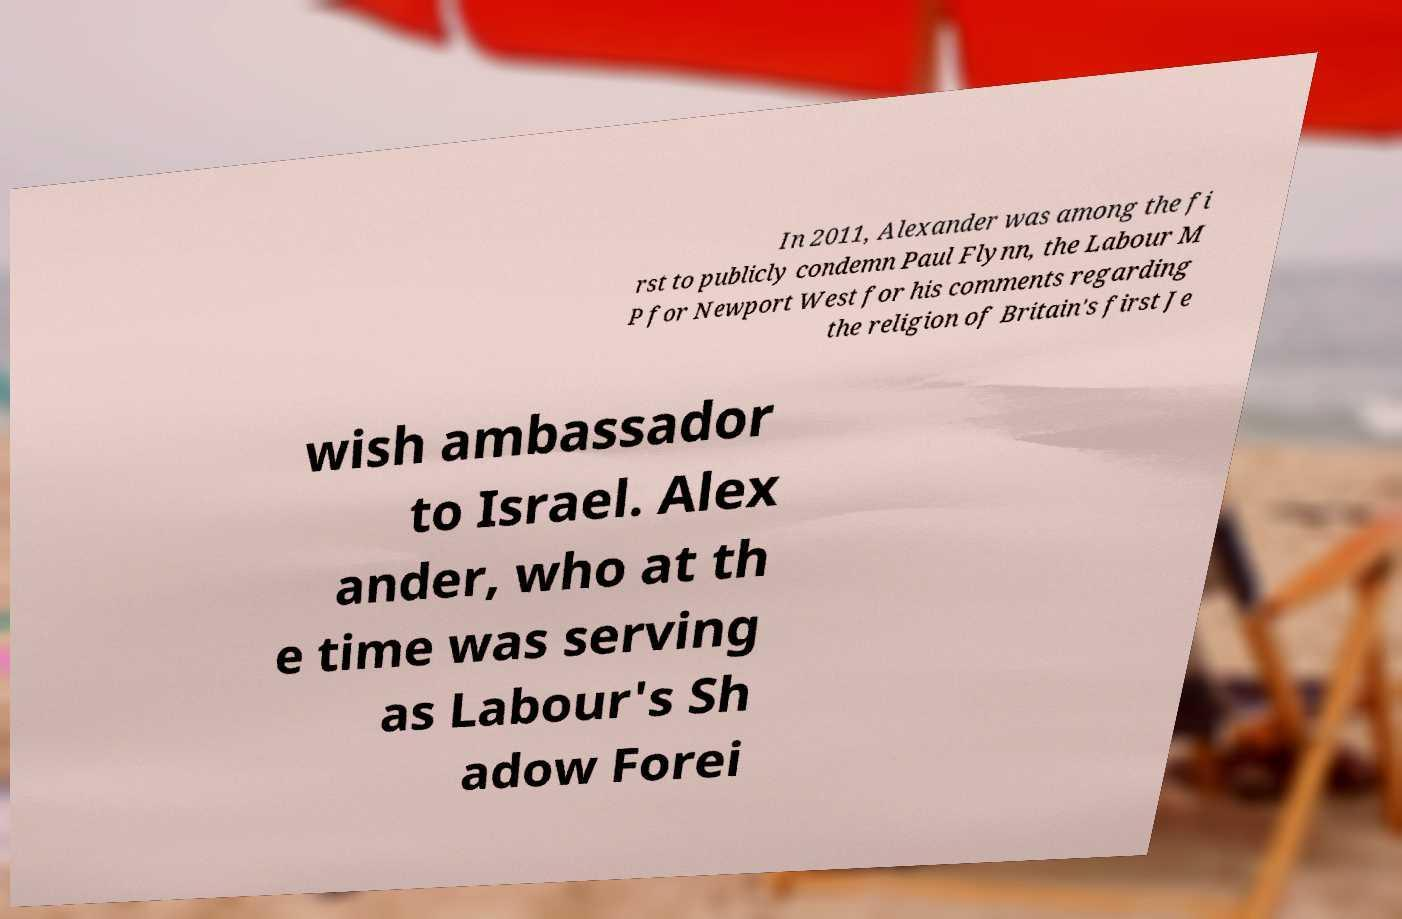I need the written content from this picture converted into text. Can you do that? In 2011, Alexander was among the fi rst to publicly condemn Paul Flynn, the Labour M P for Newport West for his comments regarding the religion of Britain's first Je wish ambassador to Israel. Alex ander, who at th e time was serving as Labour's Sh adow Forei 